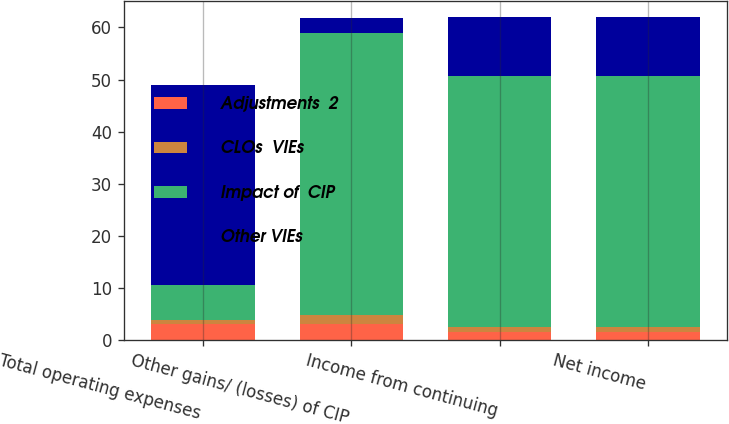<chart> <loc_0><loc_0><loc_500><loc_500><stacked_bar_chart><ecel><fcel>Total operating expenses<fcel>Other gains/ (losses) of CIP<fcel>Income from continuing<fcel>Net income<nl><fcel>Adjustments  2<fcel>3<fcel>3<fcel>1.6<fcel>1.6<nl><fcel>CLOs  VIEs<fcel>0.8<fcel>1.7<fcel>0.9<fcel>0.9<nl><fcel>Impact of  CIP<fcel>6.7<fcel>54.3<fcel>48.1<fcel>48.1<nl><fcel>Other VIEs<fcel>38.4<fcel>2.9<fcel>11.4<fcel>11.4<nl></chart> 